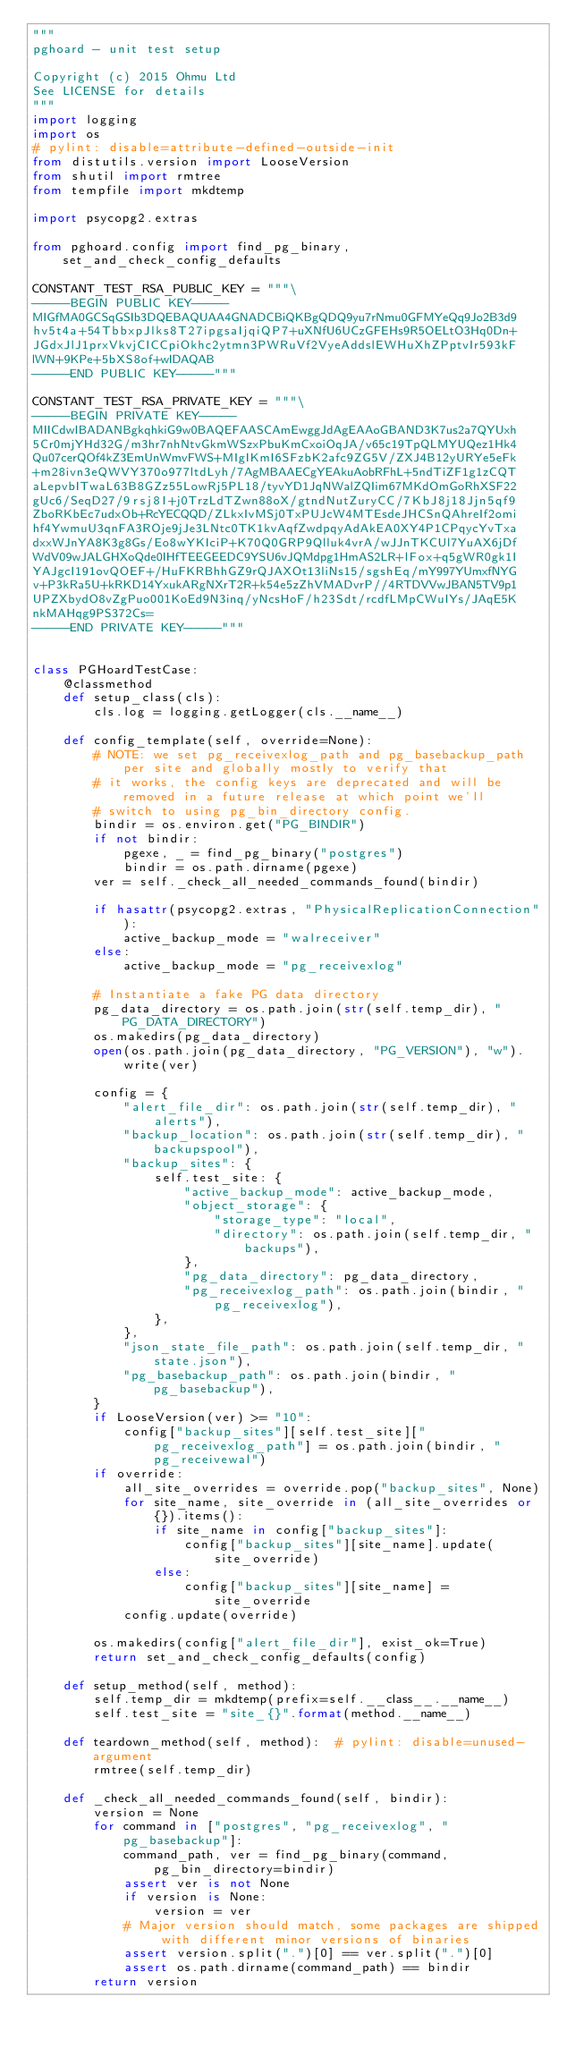<code> <loc_0><loc_0><loc_500><loc_500><_Python_>"""
pghoard - unit test setup

Copyright (c) 2015 Ohmu Ltd
See LICENSE for details
"""
import logging
import os
# pylint: disable=attribute-defined-outside-init
from distutils.version import LooseVersion
from shutil import rmtree
from tempfile import mkdtemp

import psycopg2.extras

from pghoard.config import find_pg_binary, set_and_check_config_defaults

CONSTANT_TEST_RSA_PUBLIC_KEY = """\
-----BEGIN PUBLIC KEY-----
MIGfMA0GCSqGSIb3DQEBAQUAA4GNADCBiQKBgQDQ9yu7rNmu0GFMYeQq9Jo2B3d9
hv5t4a+54TbbxpJlks8T27ipgsaIjqiQP7+uXNfU6UCzGFEHs9R5OELtO3Hq0Dn+
JGdxJlJ1prxVkvjCICCpiOkhc2ytmn3PWRuVf2VyeAddslEWHuXhZPptvIr593kF
lWN+9KPe+5bXS8of+wIDAQAB
-----END PUBLIC KEY-----"""

CONSTANT_TEST_RSA_PRIVATE_KEY = """\
-----BEGIN PRIVATE KEY-----
MIICdwIBADANBgkqhkiG9w0BAQEFAASCAmEwggJdAgEAAoGBAND3K7us2a7QYUxh
5Cr0mjYHd32G/m3hr7nhNtvGkmWSzxPbuKmCxoiOqJA/v65c19TpQLMYUQez1Hk4
Qu07cerQOf4kZ3EmUnWmvFWS+MIgIKmI6SFzbK2afc9ZG5V/ZXJ4B12yURYe5eFk
+m28ivn3eQWVY370o977ltdLyh/7AgMBAAECgYEAkuAobRFhL+5ndTiZF1g1zCQT
aLepvbITwaL63B8GZz55LowRj5PL18/tyvYD1JqNWalZQIim67MKdOmGoRhXSF22
gUc6/SeqD27/9rsj8I+j0TrzLdTZwn88oX/gtndNutZuryCC/7KbJ8j18Jjn5qf9
ZboRKbEc7udxOb+RcYECQQD/ZLkxIvMSj0TxPUJcW4MTEsdeJHCSnQAhreIf2omi
hf4YwmuU3qnFA3ROje9jJe3LNtc0TK1kvAqfZwdpqyAdAkEA0XY4P1CPqycYvTxa
dxxWJnYA8K3g8Gs/Eo8wYKIciP+K70Q0GRP9Qlluk4vrA/wJJnTKCUl7YuAX6jDf
WdV09wJALGHXoQde0IHfTEEGEEDC9YSU6vJQMdpg1HmAS2LR+lFox+q5gWR0gk1I
YAJgcI191ovQOEF+/HuFKRBhhGZ9rQJAXOt13liNs15/sgshEq/mY997YUmxfNYG
v+P3kRa5U+kRKD14YxukARgNXrT2R+k54e5zZhVMADvrP//4RTDVVwJBAN5TV9p1
UPZXbydO8vZgPuo001KoEd9N3inq/yNcsHoF/h23Sdt/rcdfLMpCWuIYs/JAqE5K
nkMAHqg9PS372Cs=
-----END PRIVATE KEY-----"""


class PGHoardTestCase:
    @classmethod
    def setup_class(cls):
        cls.log = logging.getLogger(cls.__name__)

    def config_template(self, override=None):
        # NOTE: we set pg_receivexlog_path and pg_basebackup_path per site and globally mostly to verify that
        # it works, the config keys are deprecated and will be removed in a future release at which point we'll
        # switch to using pg_bin_directory config.
        bindir = os.environ.get("PG_BINDIR")
        if not bindir:
            pgexe, _ = find_pg_binary("postgres")
            bindir = os.path.dirname(pgexe)
        ver = self._check_all_needed_commands_found(bindir)

        if hasattr(psycopg2.extras, "PhysicalReplicationConnection"):
            active_backup_mode = "walreceiver"
        else:
            active_backup_mode = "pg_receivexlog"

        # Instantiate a fake PG data directory
        pg_data_directory = os.path.join(str(self.temp_dir), "PG_DATA_DIRECTORY")
        os.makedirs(pg_data_directory)
        open(os.path.join(pg_data_directory, "PG_VERSION"), "w").write(ver)

        config = {
            "alert_file_dir": os.path.join(str(self.temp_dir), "alerts"),
            "backup_location": os.path.join(str(self.temp_dir), "backupspool"),
            "backup_sites": {
                self.test_site: {
                    "active_backup_mode": active_backup_mode,
                    "object_storage": {
                        "storage_type": "local",
                        "directory": os.path.join(self.temp_dir, "backups"),
                    },
                    "pg_data_directory": pg_data_directory,
                    "pg_receivexlog_path": os.path.join(bindir, "pg_receivexlog"),
                },
            },
            "json_state_file_path": os.path.join(self.temp_dir, "state.json"),
            "pg_basebackup_path": os.path.join(bindir, "pg_basebackup"),
        }
        if LooseVersion(ver) >= "10":
            config["backup_sites"][self.test_site]["pg_receivexlog_path"] = os.path.join(bindir, "pg_receivewal")
        if override:
            all_site_overrides = override.pop("backup_sites", None)
            for site_name, site_override in (all_site_overrides or {}).items():
                if site_name in config["backup_sites"]:
                    config["backup_sites"][site_name].update(site_override)
                else:
                    config["backup_sites"][site_name] = site_override
            config.update(override)

        os.makedirs(config["alert_file_dir"], exist_ok=True)
        return set_and_check_config_defaults(config)

    def setup_method(self, method):
        self.temp_dir = mkdtemp(prefix=self.__class__.__name__)
        self.test_site = "site_{}".format(method.__name__)

    def teardown_method(self, method):  # pylint: disable=unused-argument
        rmtree(self.temp_dir)

    def _check_all_needed_commands_found(self, bindir):
        version = None
        for command in ["postgres", "pg_receivexlog", "pg_basebackup"]:
            command_path, ver = find_pg_binary(command, pg_bin_directory=bindir)
            assert ver is not None
            if version is None:
                version = ver
            # Major version should match, some packages are shipped with different minor versions of binaries
            assert version.split(".")[0] == ver.split(".")[0]
            assert os.path.dirname(command_path) == bindir
        return version
</code> 